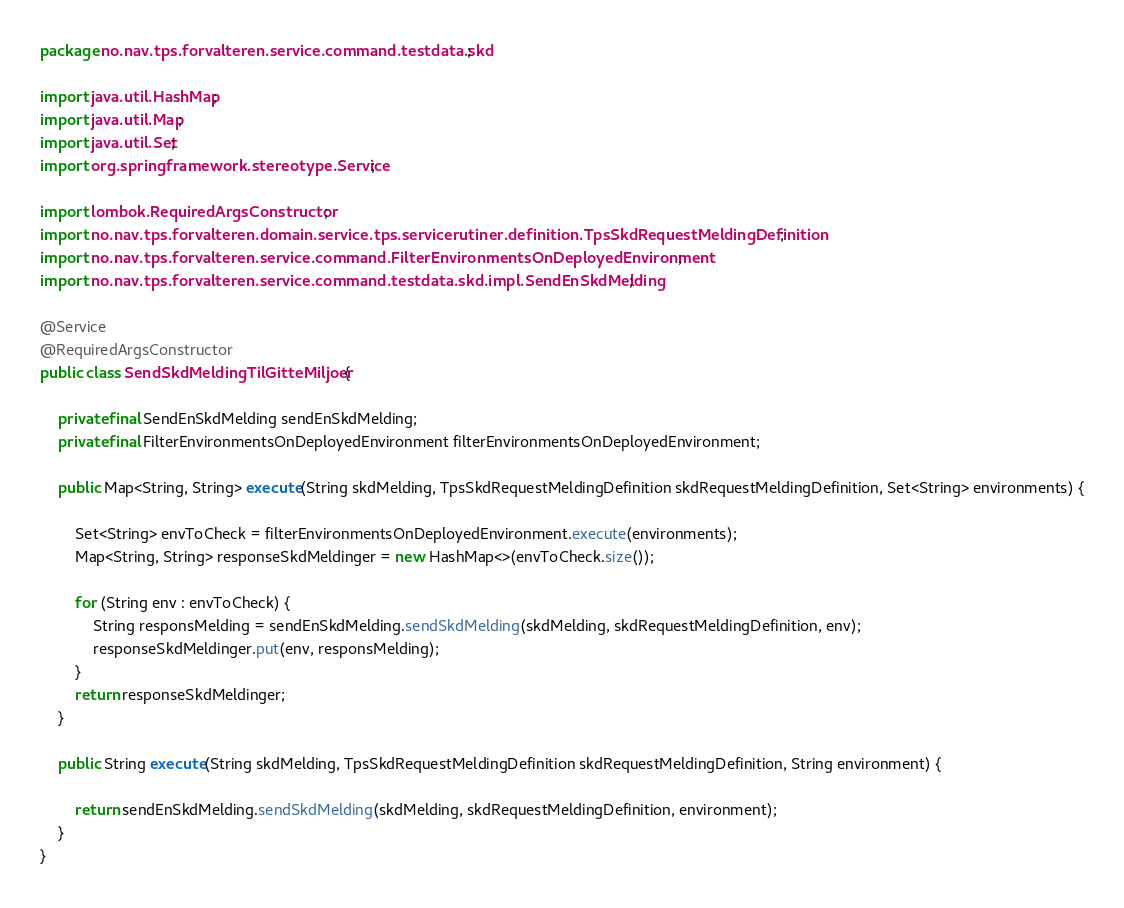<code> <loc_0><loc_0><loc_500><loc_500><_Java_>package no.nav.tps.forvalteren.service.command.testdata.skd;

import java.util.HashMap;
import java.util.Map;
import java.util.Set;
import org.springframework.stereotype.Service;

import lombok.RequiredArgsConstructor;
import no.nav.tps.forvalteren.domain.service.tps.servicerutiner.definition.TpsSkdRequestMeldingDefinition;
import no.nav.tps.forvalteren.service.command.FilterEnvironmentsOnDeployedEnvironment;
import no.nav.tps.forvalteren.service.command.testdata.skd.impl.SendEnSkdMelding;

@Service
@RequiredArgsConstructor
public class SendSkdMeldingTilGitteMiljoer {

    private final SendEnSkdMelding sendEnSkdMelding;
    private final FilterEnvironmentsOnDeployedEnvironment filterEnvironmentsOnDeployedEnvironment;

    public Map<String, String> execute(String skdMelding, TpsSkdRequestMeldingDefinition skdRequestMeldingDefinition, Set<String> environments) {

        Set<String> envToCheck = filterEnvironmentsOnDeployedEnvironment.execute(environments);
        Map<String, String> responseSkdMeldinger = new HashMap<>(envToCheck.size());

        for (String env : envToCheck) {
            String responsMelding = sendEnSkdMelding.sendSkdMelding(skdMelding, skdRequestMeldingDefinition, env);
            responseSkdMeldinger.put(env, responsMelding);
        }
        return responseSkdMeldinger;
    }

    public String execute(String skdMelding, TpsSkdRequestMeldingDefinition skdRequestMeldingDefinition, String environment) {

        return sendEnSkdMelding.sendSkdMelding(skdMelding, skdRequestMeldingDefinition, environment);
    }
}
</code> 